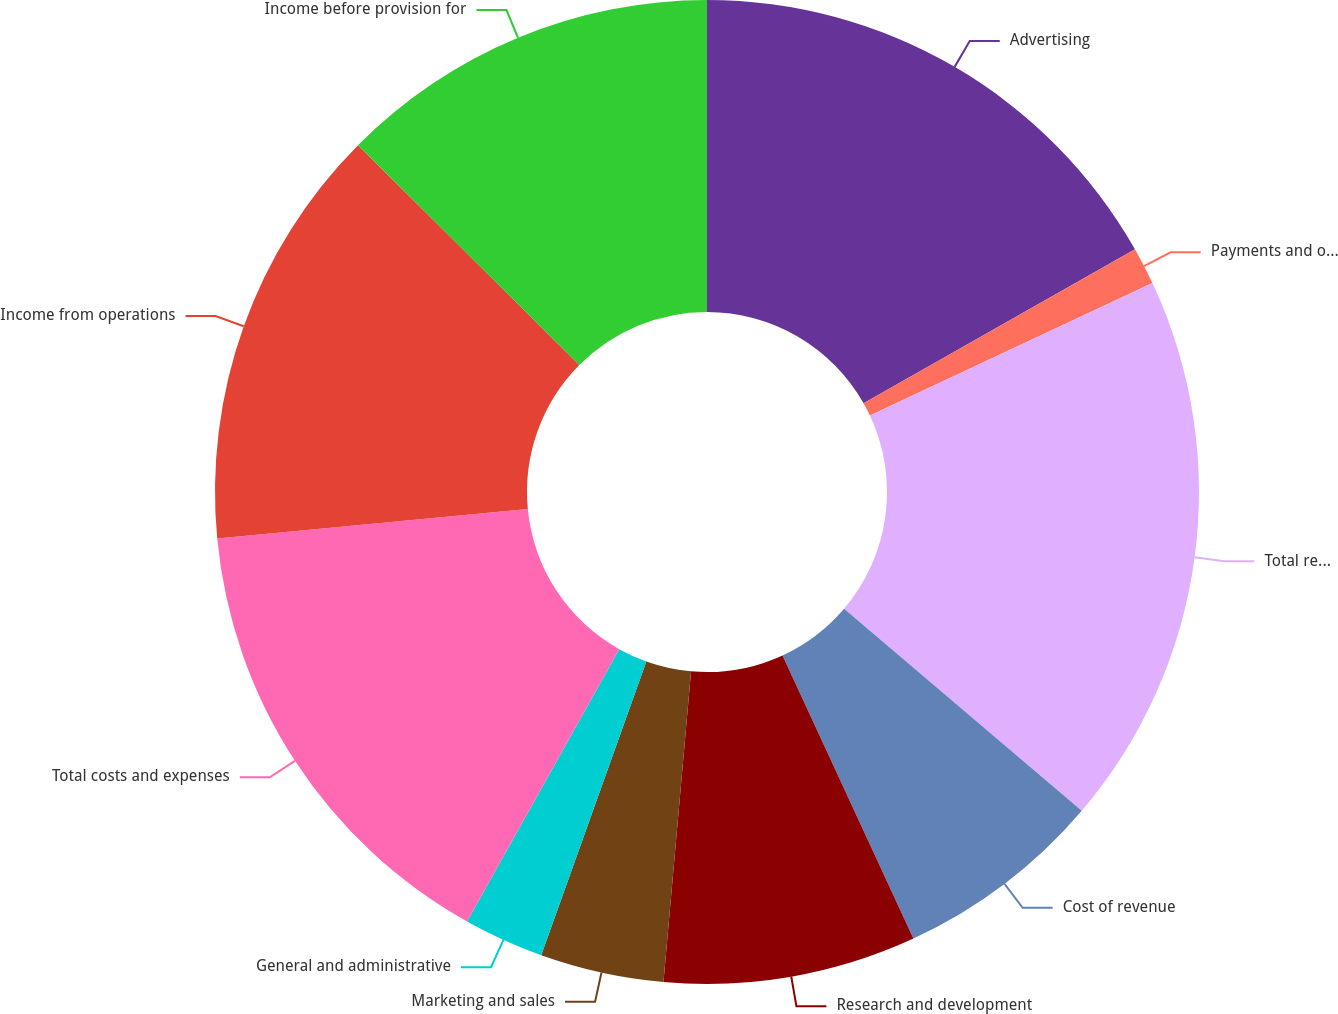<chart> <loc_0><loc_0><loc_500><loc_500><pie_chart><fcel>Advertising<fcel>Payments and other fees<fcel>Total revenue<fcel>Cost of revenue<fcel>Research and development<fcel>Marketing and sales<fcel>General and administrative<fcel>Total costs and expenses<fcel>Income from operations<fcel>Income before provision for<nl><fcel>16.79%<fcel>1.23%<fcel>18.2%<fcel>6.89%<fcel>8.3%<fcel>4.06%<fcel>2.64%<fcel>15.38%<fcel>13.96%<fcel>12.55%<nl></chart> 